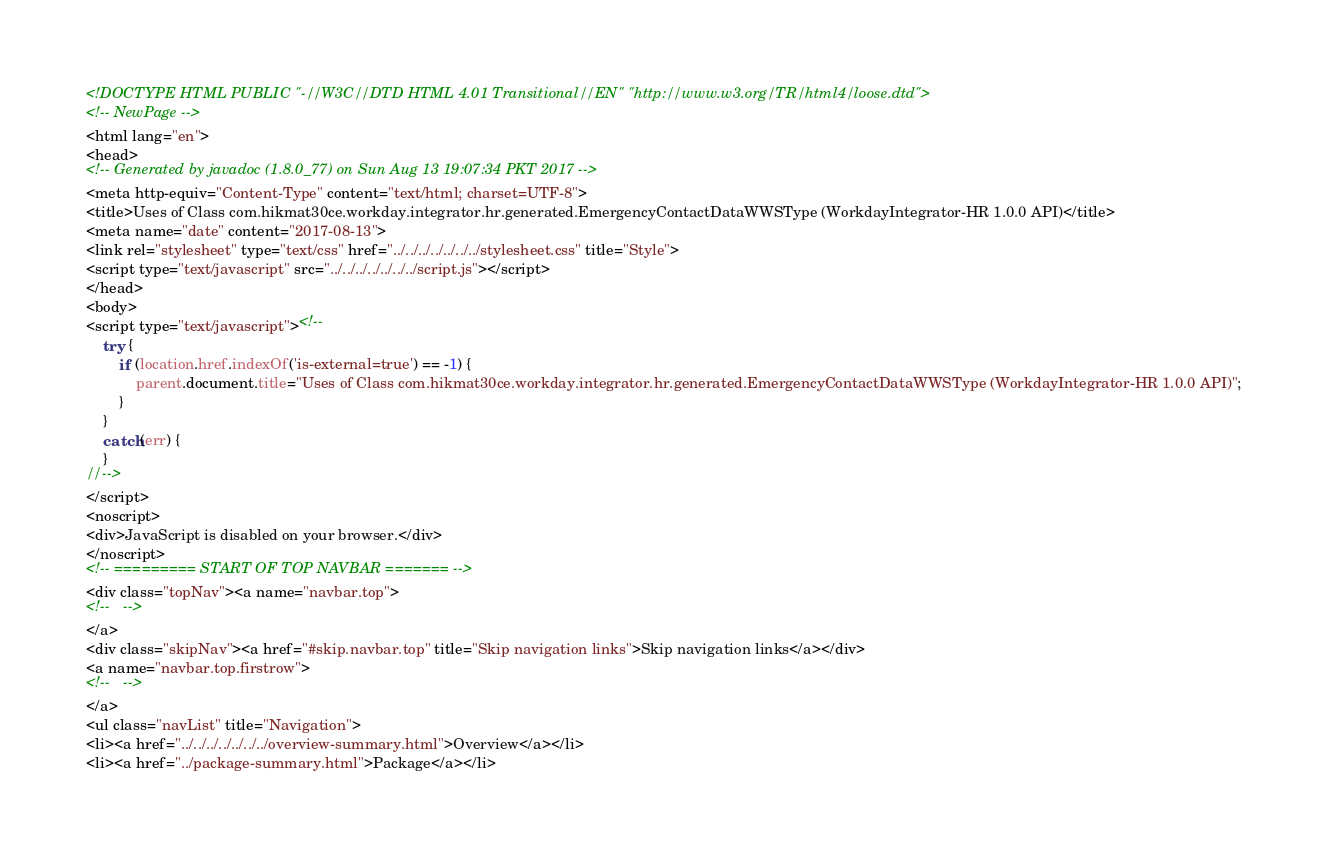<code> <loc_0><loc_0><loc_500><loc_500><_HTML_><!DOCTYPE HTML PUBLIC "-//W3C//DTD HTML 4.01 Transitional//EN" "http://www.w3.org/TR/html4/loose.dtd">
<!-- NewPage -->
<html lang="en">
<head>
<!-- Generated by javadoc (1.8.0_77) on Sun Aug 13 19:07:34 PKT 2017 -->
<meta http-equiv="Content-Type" content="text/html; charset=UTF-8">
<title>Uses of Class com.hikmat30ce.workday.integrator.hr.generated.EmergencyContactDataWWSType (WorkdayIntegrator-HR 1.0.0 API)</title>
<meta name="date" content="2017-08-13">
<link rel="stylesheet" type="text/css" href="../../../../../../../stylesheet.css" title="Style">
<script type="text/javascript" src="../../../../../../../script.js"></script>
</head>
<body>
<script type="text/javascript"><!--
    try {
        if (location.href.indexOf('is-external=true') == -1) {
            parent.document.title="Uses of Class com.hikmat30ce.workday.integrator.hr.generated.EmergencyContactDataWWSType (WorkdayIntegrator-HR 1.0.0 API)";
        }
    }
    catch(err) {
    }
//-->
</script>
<noscript>
<div>JavaScript is disabled on your browser.</div>
</noscript>
<!-- ========= START OF TOP NAVBAR ======= -->
<div class="topNav"><a name="navbar.top">
<!--   -->
</a>
<div class="skipNav"><a href="#skip.navbar.top" title="Skip navigation links">Skip navigation links</a></div>
<a name="navbar.top.firstrow">
<!--   -->
</a>
<ul class="navList" title="Navigation">
<li><a href="../../../../../../../overview-summary.html">Overview</a></li>
<li><a href="../package-summary.html">Package</a></li></code> 